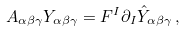Convert formula to latex. <formula><loc_0><loc_0><loc_500><loc_500>A _ { \alpha \beta \gamma } Y _ { \alpha \beta \gamma } = F ^ { I } \partial _ { I } \hat { Y } _ { \alpha \beta \gamma } \, ,</formula> 